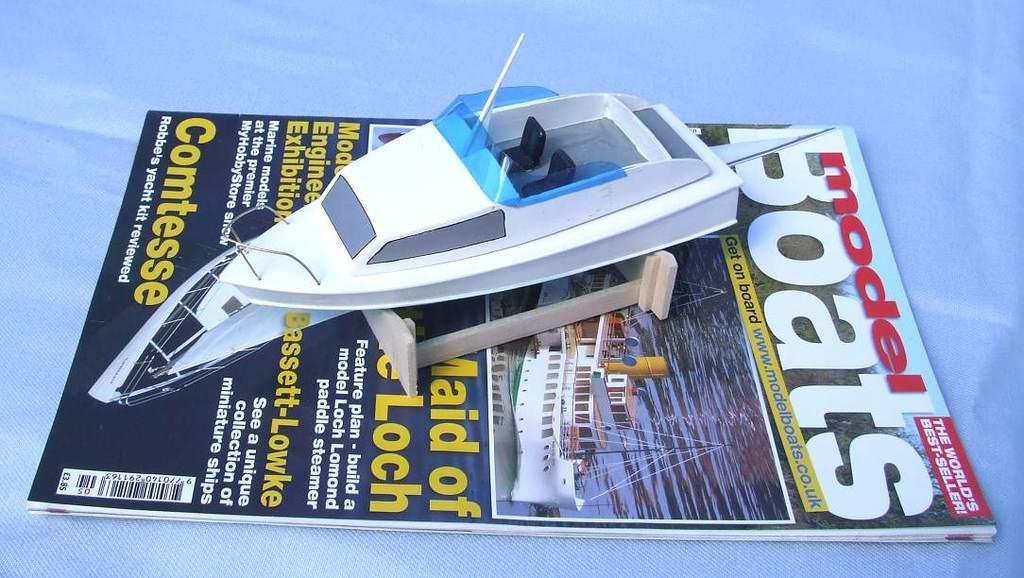What is the magazine title?
Your response must be concise. Model boats. 